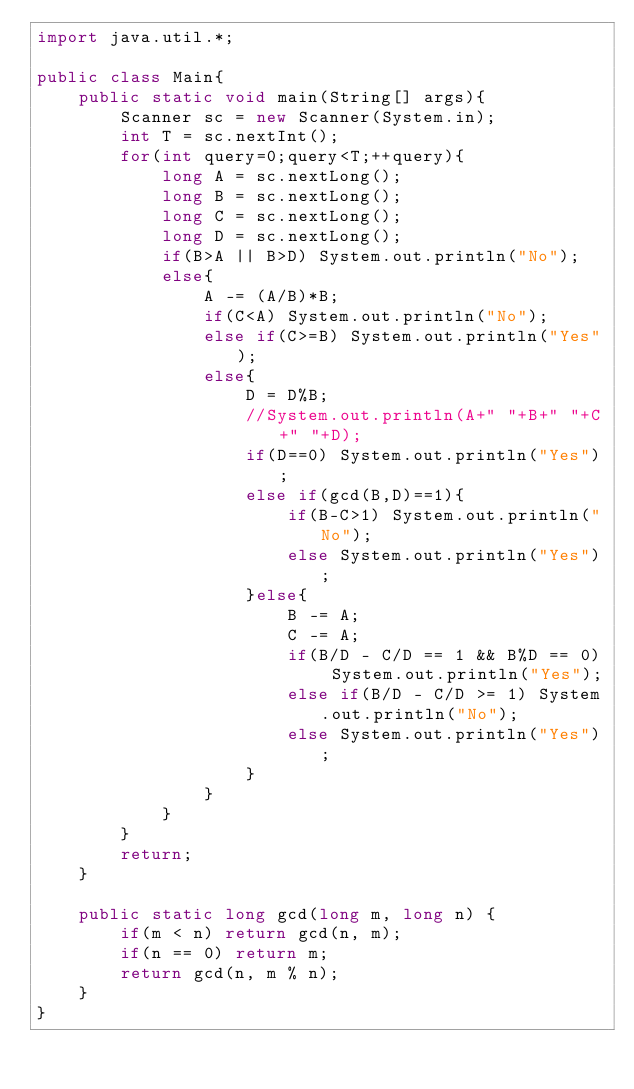<code> <loc_0><loc_0><loc_500><loc_500><_Java_>import java.util.*;
 
public class Main{
	public static void main(String[] args){
		Scanner sc = new Scanner(System.in);
		int T = sc.nextInt();
		for(int query=0;query<T;++query){
			long A = sc.nextLong();
			long B = sc.nextLong();
			long C = sc.nextLong();
			long D = sc.nextLong();
			if(B>A || B>D) System.out.println("No");
			else{
				A -= (A/B)*B;
				if(C<A) System.out.println("No");
				else if(C>=B) System.out.println("Yes");
				else{
					D = D%B;
					//System.out.println(A+" "+B+" "+C+" "+D);
					if(D==0) System.out.println("Yes");
					else if(gcd(B,D)==1){
						if(B-C>1) System.out.println("No");
						else System.out.println("Yes");
					}else{
						B -= A;
						C -= A;
						if(B/D - C/D == 1 && B%D == 0) System.out.println("Yes");
						else if(B/D - C/D >= 1) System.out.println("No");
						else System.out.println("Yes");
					}
				}
			}
		}
		return;
	}

	public static long gcd(long m, long n) {
		if(m < n) return gcd(n, m);
		if(n == 0) return m;
		return gcd(n, m % n);
	}
}</code> 